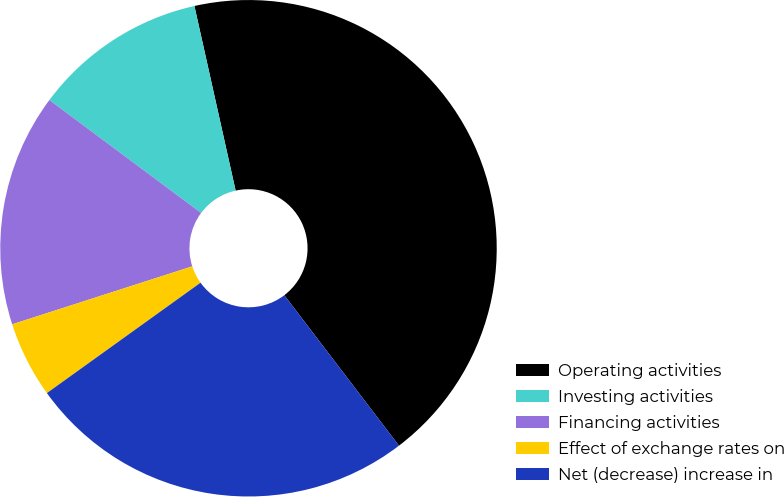Convert chart. <chart><loc_0><loc_0><loc_500><loc_500><pie_chart><fcel>Operating activities<fcel>Investing activities<fcel>Financing activities<fcel>Effect of exchange rates on<fcel>Net (decrease) increase in<nl><fcel>43.13%<fcel>11.32%<fcel>15.14%<fcel>4.96%<fcel>25.45%<nl></chart> 